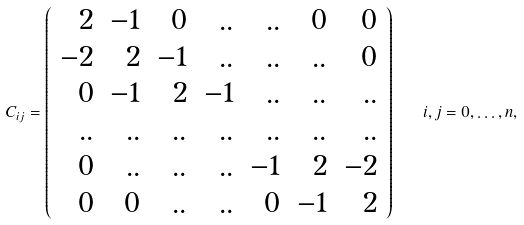Convert formula to latex. <formula><loc_0><loc_0><loc_500><loc_500>C _ { i j } = \left ( \begin{array} { r r r r r r r r r } 2 & - 1 & 0 & . . & . . & 0 & 0 \\ - 2 & 2 & - 1 & . . & . . & . . & 0 \\ 0 & - 1 & 2 & - 1 & . . & . . & . . \\ . . & . . & . . & . . & . . & . . & . . \\ 0 & . . & . . & . . & - 1 & 2 & - 2 \\ 0 & 0 & . . & . . & 0 & - 1 & 2 \\ \end{array} \right ) \quad i , j = 0 , \dots , n ,</formula> 